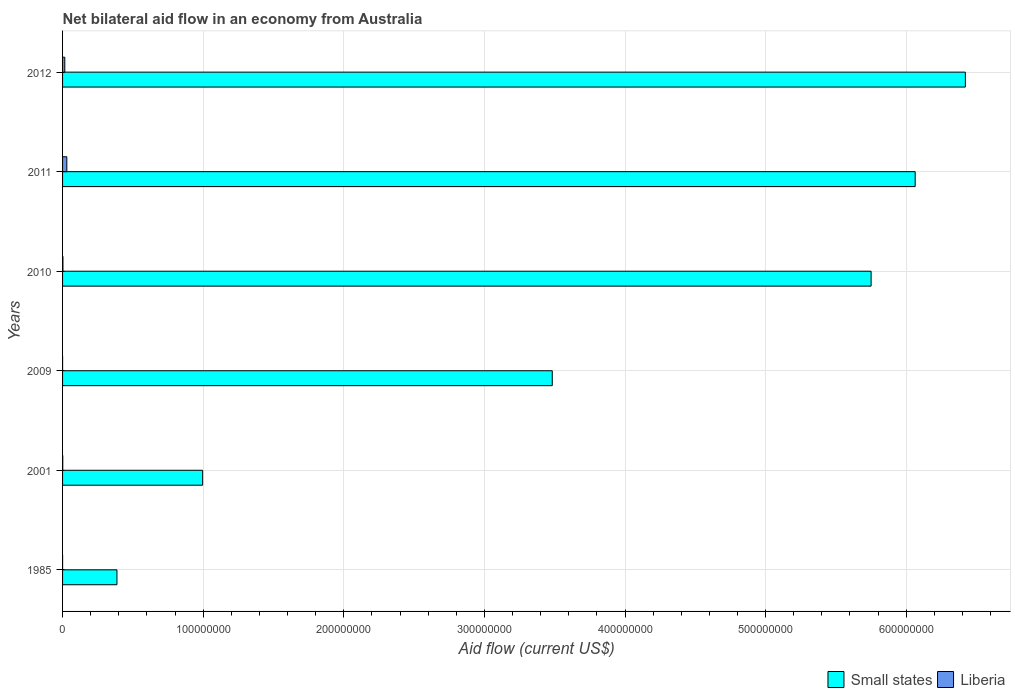In how many cases, is the number of bars for a given year not equal to the number of legend labels?
Provide a succinct answer. 0. Across all years, what is the maximum net bilateral aid flow in Small states?
Offer a very short reply. 6.42e+08. Across all years, what is the minimum net bilateral aid flow in Liberia?
Make the answer very short. 10000. In which year was the net bilateral aid flow in Liberia maximum?
Offer a very short reply. 2011. In which year was the net bilateral aid flow in Small states minimum?
Make the answer very short. 1985. What is the total net bilateral aid flow in Liberia in the graph?
Keep it short and to the point. 5.04e+06. What is the difference between the net bilateral aid flow in Small states in 1985 and that in 2012?
Offer a very short reply. -6.03e+08. What is the difference between the net bilateral aid flow in Liberia in 2009 and the net bilateral aid flow in Small states in 2011?
Make the answer very short. -6.06e+08. What is the average net bilateral aid flow in Small states per year?
Keep it short and to the point. 3.85e+08. In the year 2012, what is the difference between the net bilateral aid flow in Small states and net bilateral aid flow in Liberia?
Your response must be concise. 6.40e+08. What is the ratio of the net bilateral aid flow in Liberia in 2001 to that in 2011?
Keep it short and to the point. 0.04. Is the net bilateral aid flow in Liberia in 1985 less than that in 2010?
Ensure brevity in your answer.  Yes. Is the difference between the net bilateral aid flow in Small states in 1985 and 2001 greater than the difference between the net bilateral aid flow in Liberia in 1985 and 2001?
Keep it short and to the point. No. What is the difference between the highest and the second highest net bilateral aid flow in Liberia?
Give a very brief answer. 1.44e+06. What is the difference between the highest and the lowest net bilateral aid flow in Small states?
Your answer should be very brief. 6.03e+08. In how many years, is the net bilateral aid flow in Liberia greater than the average net bilateral aid flow in Liberia taken over all years?
Your answer should be very brief. 2. Is the sum of the net bilateral aid flow in Liberia in 2009 and 2012 greater than the maximum net bilateral aid flow in Small states across all years?
Offer a very short reply. No. What does the 1st bar from the top in 2001 represents?
Provide a short and direct response. Liberia. What does the 2nd bar from the bottom in 1985 represents?
Make the answer very short. Liberia. How many bars are there?
Provide a succinct answer. 12. Are all the bars in the graph horizontal?
Provide a short and direct response. Yes. What is the difference between two consecutive major ticks on the X-axis?
Keep it short and to the point. 1.00e+08. Does the graph contain grids?
Give a very brief answer. Yes. Where does the legend appear in the graph?
Your answer should be compact. Bottom right. How many legend labels are there?
Give a very brief answer. 2. What is the title of the graph?
Offer a very short reply. Net bilateral aid flow in an economy from Australia. What is the label or title of the Y-axis?
Provide a succinct answer. Years. What is the Aid flow (current US$) in Small states in 1985?
Offer a very short reply. 3.87e+07. What is the Aid flow (current US$) in Liberia in 1985?
Your answer should be very brief. 2.00e+04. What is the Aid flow (current US$) of Small states in 2001?
Your answer should be compact. 9.96e+07. What is the Aid flow (current US$) in Liberia in 2001?
Make the answer very short. 1.30e+05. What is the Aid flow (current US$) of Small states in 2009?
Your answer should be very brief. 3.48e+08. What is the Aid flow (current US$) of Liberia in 2009?
Provide a short and direct response. 10000. What is the Aid flow (current US$) of Small states in 2010?
Your answer should be very brief. 5.75e+08. What is the Aid flow (current US$) in Small states in 2011?
Ensure brevity in your answer.  6.06e+08. What is the Aid flow (current US$) of Liberia in 2011?
Provide a succinct answer. 3.03e+06. What is the Aid flow (current US$) in Small states in 2012?
Make the answer very short. 6.42e+08. What is the Aid flow (current US$) in Liberia in 2012?
Your answer should be compact. 1.59e+06. Across all years, what is the maximum Aid flow (current US$) of Small states?
Your response must be concise. 6.42e+08. Across all years, what is the maximum Aid flow (current US$) of Liberia?
Your response must be concise. 3.03e+06. Across all years, what is the minimum Aid flow (current US$) in Small states?
Give a very brief answer. 3.87e+07. Across all years, what is the minimum Aid flow (current US$) of Liberia?
Your answer should be very brief. 10000. What is the total Aid flow (current US$) in Small states in the graph?
Ensure brevity in your answer.  2.31e+09. What is the total Aid flow (current US$) of Liberia in the graph?
Your response must be concise. 5.04e+06. What is the difference between the Aid flow (current US$) in Small states in 1985 and that in 2001?
Ensure brevity in your answer.  -6.09e+07. What is the difference between the Aid flow (current US$) in Small states in 1985 and that in 2009?
Provide a short and direct response. -3.10e+08. What is the difference between the Aid flow (current US$) of Small states in 1985 and that in 2010?
Ensure brevity in your answer.  -5.36e+08. What is the difference between the Aid flow (current US$) in Liberia in 1985 and that in 2010?
Offer a very short reply. -2.40e+05. What is the difference between the Aid flow (current US$) of Small states in 1985 and that in 2011?
Offer a terse response. -5.68e+08. What is the difference between the Aid flow (current US$) of Liberia in 1985 and that in 2011?
Keep it short and to the point. -3.01e+06. What is the difference between the Aid flow (current US$) in Small states in 1985 and that in 2012?
Ensure brevity in your answer.  -6.03e+08. What is the difference between the Aid flow (current US$) in Liberia in 1985 and that in 2012?
Provide a succinct answer. -1.57e+06. What is the difference between the Aid flow (current US$) of Small states in 2001 and that in 2009?
Your answer should be very brief. -2.49e+08. What is the difference between the Aid flow (current US$) of Liberia in 2001 and that in 2009?
Give a very brief answer. 1.20e+05. What is the difference between the Aid flow (current US$) in Small states in 2001 and that in 2010?
Provide a succinct answer. -4.75e+08. What is the difference between the Aid flow (current US$) of Liberia in 2001 and that in 2010?
Your response must be concise. -1.30e+05. What is the difference between the Aid flow (current US$) of Small states in 2001 and that in 2011?
Keep it short and to the point. -5.07e+08. What is the difference between the Aid flow (current US$) of Liberia in 2001 and that in 2011?
Offer a terse response. -2.90e+06. What is the difference between the Aid flow (current US$) of Small states in 2001 and that in 2012?
Offer a very short reply. -5.42e+08. What is the difference between the Aid flow (current US$) of Liberia in 2001 and that in 2012?
Provide a succinct answer. -1.46e+06. What is the difference between the Aid flow (current US$) of Small states in 2009 and that in 2010?
Your answer should be very brief. -2.27e+08. What is the difference between the Aid flow (current US$) of Liberia in 2009 and that in 2010?
Ensure brevity in your answer.  -2.50e+05. What is the difference between the Aid flow (current US$) of Small states in 2009 and that in 2011?
Make the answer very short. -2.58e+08. What is the difference between the Aid flow (current US$) of Liberia in 2009 and that in 2011?
Provide a short and direct response. -3.02e+06. What is the difference between the Aid flow (current US$) of Small states in 2009 and that in 2012?
Your response must be concise. -2.94e+08. What is the difference between the Aid flow (current US$) in Liberia in 2009 and that in 2012?
Your response must be concise. -1.58e+06. What is the difference between the Aid flow (current US$) of Small states in 2010 and that in 2011?
Provide a short and direct response. -3.14e+07. What is the difference between the Aid flow (current US$) in Liberia in 2010 and that in 2011?
Your response must be concise. -2.77e+06. What is the difference between the Aid flow (current US$) in Small states in 2010 and that in 2012?
Your answer should be compact. -6.70e+07. What is the difference between the Aid flow (current US$) of Liberia in 2010 and that in 2012?
Your answer should be very brief. -1.33e+06. What is the difference between the Aid flow (current US$) of Small states in 2011 and that in 2012?
Give a very brief answer. -3.57e+07. What is the difference between the Aid flow (current US$) in Liberia in 2011 and that in 2012?
Ensure brevity in your answer.  1.44e+06. What is the difference between the Aid flow (current US$) in Small states in 1985 and the Aid flow (current US$) in Liberia in 2001?
Offer a terse response. 3.86e+07. What is the difference between the Aid flow (current US$) in Small states in 1985 and the Aid flow (current US$) in Liberia in 2009?
Ensure brevity in your answer.  3.87e+07. What is the difference between the Aid flow (current US$) of Small states in 1985 and the Aid flow (current US$) of Liberia in 2010?
Provide a succinct answer. 3.84e+07. What is the difference between the Aid flow (current US$) of Small states in 1985 and the Aid flow (current US$) of Liberia in 2011?
Give a very brief answer. 3.56e+07. What is the difference between the Aid flow (current US$) of Small states in 1985 and the Aid flow (current US$) of Liberia in 2012?
Keep it short and to the point. 3.71e+07. What is the difference between the Aid flow (current US$) in Small states in 2001 and the Aid flow (current US$) in Liberia in 2009?
Keep it short and to the point. 9.96e+07. What is the difference between the Aid flow (current US$) in Small states in 2001 and the Aid flow (current US$) in Liberia in 2010?
Offer a very short reply. 9.94e+07. What is the difference between the Aid flow (current US$) in Small states in 2001 and the Aid flow (current US$) in Liberia in 2011?
Provide a succinct answer. 9.66e+07. What is the difference between the Aid flow (current US$) in Small states in 2001 and the Aid flow (current US$) in Liberia in 2012?
Provide a succinct answer. 9.80e+07. What is the difference between the Aid flow (current US$) in Small states in 2009 and the Aid flow (current US$) in Liberia in 2010?
Ensure brevity in your answer.  3.48e+08. What is the difference between the Aid flow (current US$) in Small states in 2009 and the Aid flow (current US$) in Liberia in 2011?
Make the answer very short. 3.45e+08. What is the difference between the Aid flow (current US$) of Small states in 2009 and the Aid flow (current US$) of Liberia in 2012?
Give a very brief answer. 3.47e+08. What is the difference between the Aid flow (current US$) in Small states in 2010 and the Aid flow (current US$) in Liberia in 2011?
Make the answer very short. 5.72e+08. What is the difference between the Aid flow (current US$) of Small states in 2010 and the Aid flow (current US$) of Liberia in 2012?
Give a very brief answer. 5.73e+08. What is the difference between the Aid flow (current US$) of Small states in 2011 and the Aid flow (current US$) of Liberia in 2012?
Offer a terse response. 6.05e+08. What is the average Aid flow (current US$) in Small states per year?
Keep it short and to the point. 3.85e+08. What is the average Aid flow (current US$) in Liberia per year?
Give a very brief answer. 8.40e+05. In the year 1985, what is the difference between the Aid flow (current US$) in Small states and Aid flow (current US$) in Liberia?
Provide a short and direct response. 3.87e+07. In the year 2001, what is the difference between the Aid flow (current US$) in Small states and Aid flow (current US$) in Liberia?
Give a very brief answer. 9.95e+07. In the year 2009, what is the difference between the Aid flow (current US$) in Small states and Aid flow (current US$) in Liberia?
Your answer should be compact. 3.48e+08. In the year 2010, what is the difference between the Aid flow (current US$) of Small states and Aid flow (current US$) of Liberia?
Give a very brief answer. 5.75e+08. In the year 2011, what is the difference between the Aid flow (current US$) in Small states and Aid flow (current US$) in Liberia?
Your answer should be very brief. 6.03e+08. In the year 2012, what is the difference between the Aid flow (current US$) of Small states and Aid flow (current US$) of Liberia?
Your response must be concise. 6.40e+08. What is the ratio of the Aid flow (current US$) in Small states in 1985 to that in 2001?
Your response must be concise. 0.39. What is the ratio of the Aid flow (current US$) of Liberia in 1985 to that in 2001?
Provide a short and direct response. 0.15. What is the ratio of the Aid flow (current US$) of Liberia in 1985 to that in 2009?
Provide a succinct answer. 2. What is the ratio of the Aid flow (current US$) of Small states in 1985 to that in 2010?
Make the answer very short. 0.07. What is the ratio of the Aid flow (current US$) of Liberia in 1985 to that in 2010?
Offer a terse response. 0.08. What is the ratio of the Aid flow (current US$) in Small states in 1985 to that in 2011?
Give a very brief answer. 0.06. What is the ratio of the Aid flow (current US$) in Liberia in 1985 to that in 2011?
Provide a succinct answer. 0.01. What is the ratio of the Aid flow (current US$) in Small states in 1985 to that in 2012?
Your answer should be very brief. 0.06. What is the ratio of the Aid flow (current US$) of Liberia in 1985 to that in 2012?
Offer a terse response. 0.01. What is the ratio of the Aid flow (current US$) in Small states in 2001 to that in 2009?
Provide a succinct answer. 0.29. What is the ratio of the Aid flow (current US$) in Liberia in 2001 to that in 2009?
Your response must be concise. 13. What is the ratio of the Aid flow (current US$) of Small states in 2001 to that in 2010?
Make the answer very short. 0.17. What is the ratio of the Aid flow (current US$) in Liberia in 2001 to that in 2010?
Make the answer very short. 0.5. What is the ratio of the Aid flow (current US$) in Small states in 2001 to that in 2011?
Provide a short and direct response. 0.16. What is the ratio of the Aid flow (current US$) in Liberia in 2001 to that in 2011?
Make the answer very short. 0.04. What is the ratio of the Aid flow (current US$) of Small states in 2001 to that in 2012?
Your response must be concise. 0.16. What is the ratio of the Aid flow (current US$) of Liberia in 2001 to that in 2012?
Give a very brief answer. 0.08. What is the ratio of the Aid flow (current US$) in Small states in 2009 to that in 2010?
Your answer should be very brief. 0.61. What is the ratio of the Aid flow (current US$) of Liberia in 2009 to that in 2010?
Offer a very short reply. 0.04. What is the ratio of the Aid flow (current US$) of Small states in 2009 to that in 2011?
Give a very brief answer. 0.57. What is the ratio of the Aid flow (current US$) in Liberia in 2009 to that in 2011?
Give a very brief answer. 0. What is the ratio of the Aid flow (current US$) of Small states in 2009 to that in 2012?
Your answer should be compact. 0.54. What is the ratio of the Aid flow (current US$) of Liberia in 2009 to that in 2012?
Your response must be concise. 0.01. What is the ratio of the Aid flow (current US$) in Small states in 2010 to that in 2011?
Offer a very short reply. 0.95. What is the ratio of the Aid flow (current US$) of Liberia in 2010 to that in 2011?
Provide a short and direct response. 0.09. What is the ratio of the Aid flow (current US$) of Small states in 2010 to that in 2012?
Offer a very short reply. 0.9. What is the ratio of the Aid flow (current US$) in Liberia in 2010 to that in 2012?
Offer a very short reply. 0.16. What is the ratio of the Aid flow (current US$) in Liberia in 2011 to that in 2012?
Your response must be concise. 1.91. What is the difference between the highest and the second highest Aid flow (current US$) of Small states?
Make the answer very short. 3.57e+07. What is the difference between the highest and the second highest Aid flow (current US$) in Liberia?
Your response must be concise. 1.44e+06. What is the difference between the highest and the lowest Aid flow (current US$) of Small states?
Keep it short and to the point. 6.03e+08. What is the difference between the highest and the lowest Aid flow (current US$) in Liberia?
Provide a short and direct response. 3.02e+06. 